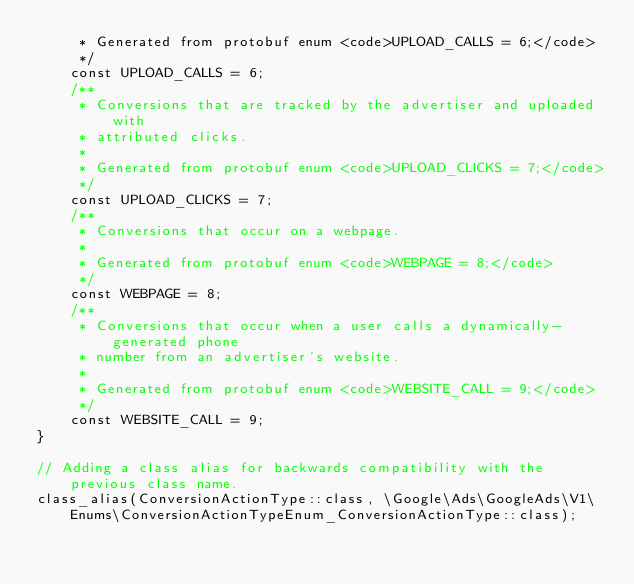Convert code to text. <code><loc_0><loc_0><loc_500><loc_500><_PHP_>     * Generated from protobuf enum <code>UPLOAD_CALLS = 6;</code>
     */
    const UPLOAD_CALLS = 6;
    /**
     * Conversions that are tracked by the advertiser and uploaded with
     * attributed clicks.
     *
     * Generated from protobuf enum <code>UPLOAD_CLICKS = 7;</code>
     */
    const UPLOAD_CLICKS = 7;
    /**
     * Conversions that occur on a webpage.
     *
     * Generated from protobuf enum <code>WEBPAGE = 8;</code>
     */
    const WEBPAGE = 8;
    /**
     * Conversions that occur when a user calls a dynamically-generated phone
     * number from an advertiser's website.
     *
     * Generated from protobuf enum <code>WEBSITE_CALL = 9;</code>
     */
    const WEBSITE_CALL = 9;
}

// Adding a class alias for backwards compatibility with the previous class name.
class_alias(ConversionActionType::class, \Google\Ads\GoogleAds\V1\Enums\ConversionActionTypeEnum_ConversionActionType::class);

</code> 